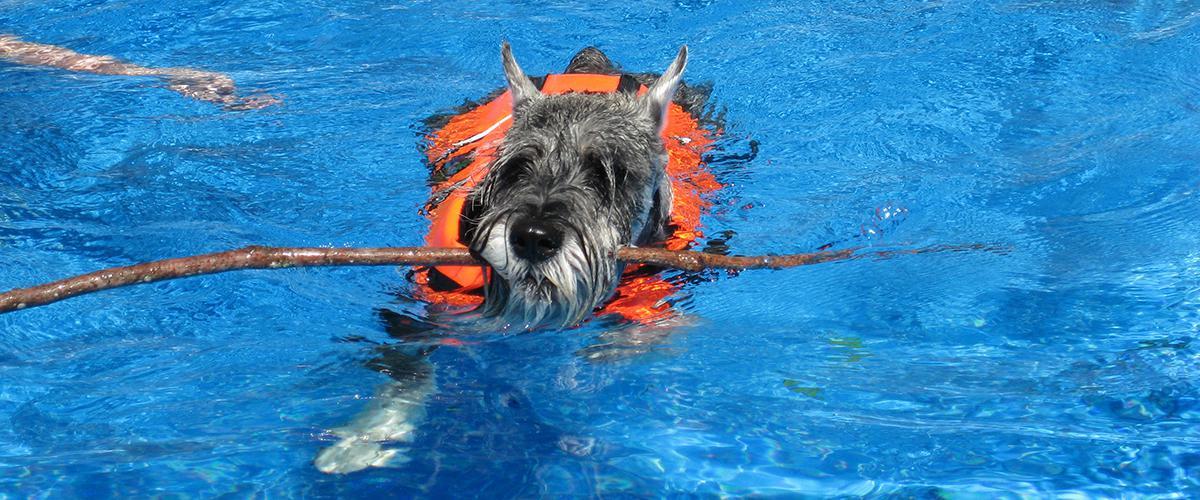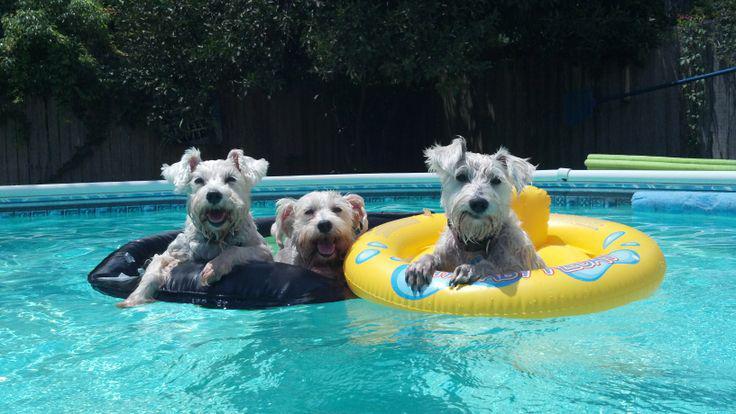The first image is the image on the left, the second image is the image on the right. Assess this claim about the two images: "There are at least four dogs in the pool.". Correct or not? Answer yes or no. Yes. The first image is the image on the left, the second image is the image on the right. For the images displayed, is the sentence "At least one dog is in an inner tube." factually correct? Answer yes or no. Yes. 